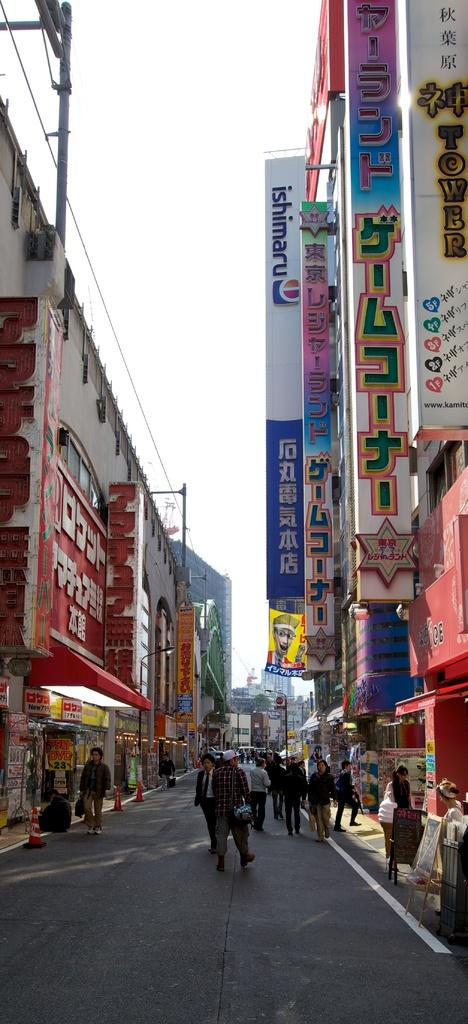What are the people in the image doing? The people in the image are walking on the road. What can be seen in the background of the image? There are buildings visible in the image. What type of objects are present in the image? There are boards present in the image. What is visible above the buildings and people? The sky is visible in the image. What type of lace can be seen on the buildings in the image? There is no lace visible on the buildings in the image. Are there any bats flying in the sky in the image? There are no bats visible in the sky in the image. 